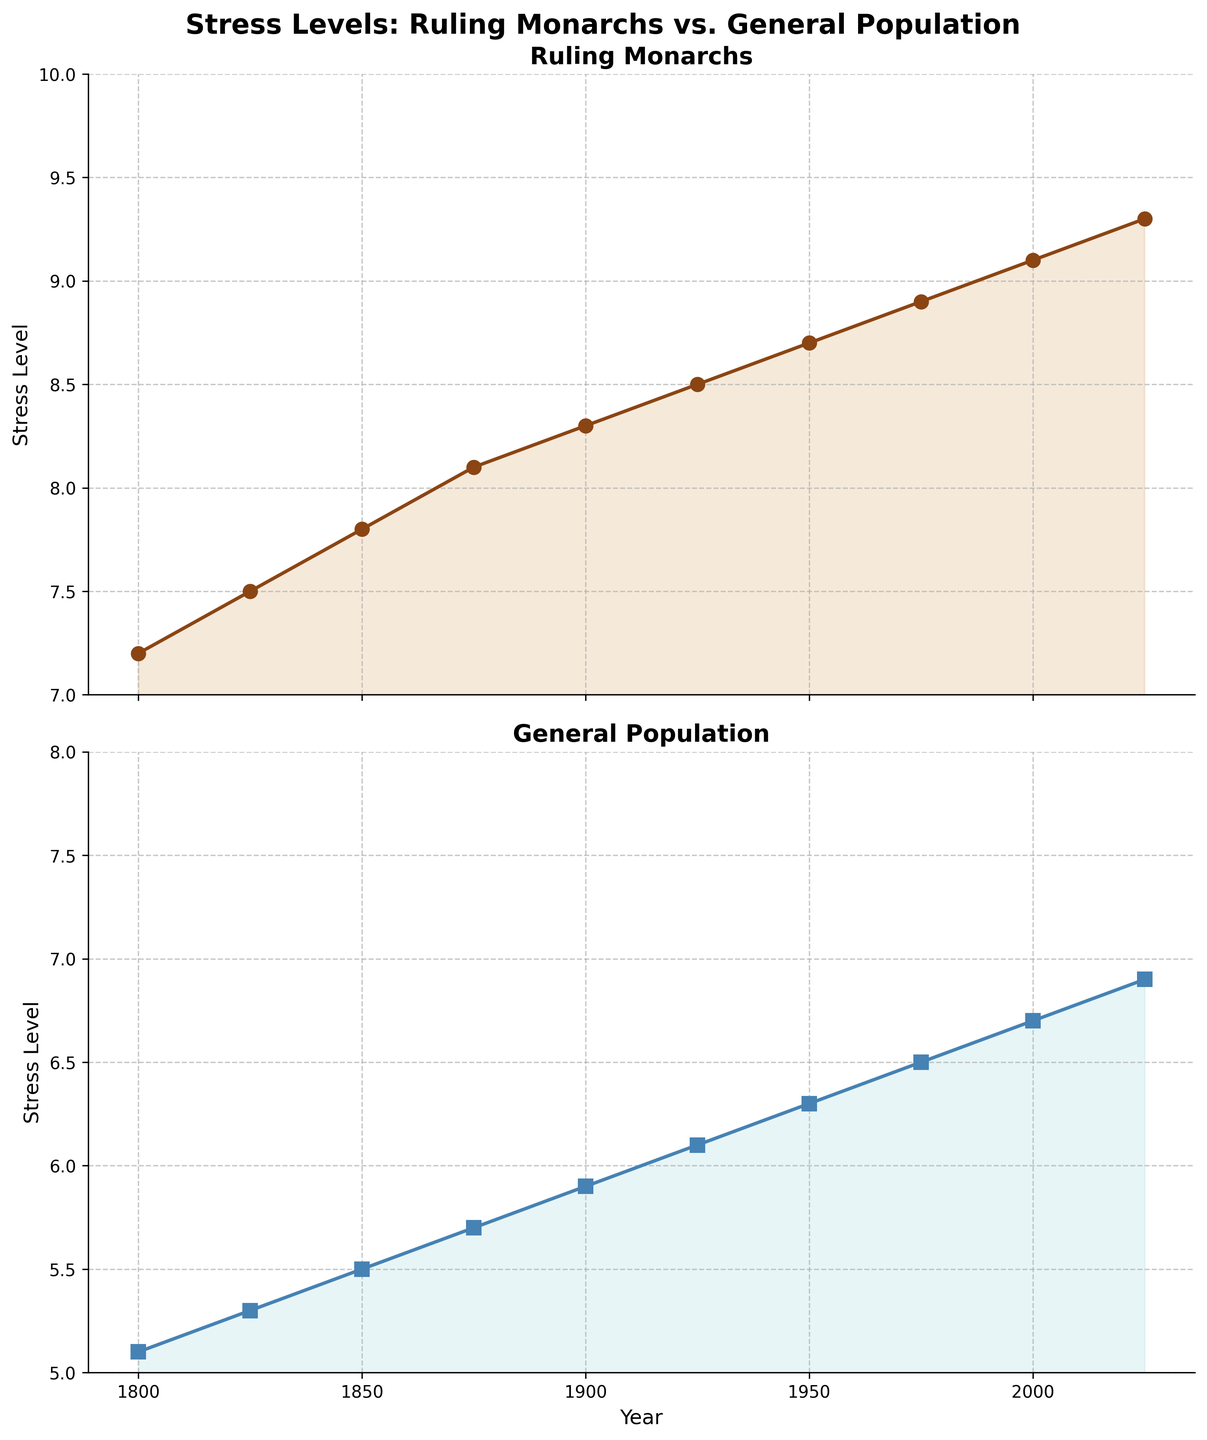What is the general trend of stress levels for ruling monarchs over time? The ruling monarchs' stress levels show a steady increase over time. From 1800 to 2025, the levels rise from 7.2 to 9.3.
Answer: An upward trend Compare the stress levels of ruling monarchs and the general population in the year 1900. Which is higher and by how much? In 1900, the stress level of ruling monarchs is 8.3, and for the general population, it is 5.9. The monarchs' stress levels are higher by 8.3 - 5.9 = 2.4.
Answer: Ruling monarchs, by 2.4 Between 1850 and 1900, which group shows a steeper increase in stress levels? For ruling monarchs, the increase is 8.3 - 7.8 = 0.5, and for the general population, it is 5.9 - 5.5 = 0.4. Monarchs have a steeper increase by 0.1.
Answer: Ruling monarchs Identify the time period (a span of 25 years) where the general population's stress level increased the most. Stress levels change: 1825-1800: 5.3-5.1=0.2, 1850-1825: 5.5-5.3=0.2, 1875-1850: 5.7-5.5=0.2, 1900-1875: 5.9-5.7=0.2, 1925-1900: 6.1-5.9=0.2, 1950-1925: 6.3-6.1=0.2, 1975-1950: 6.5-6.3=0.2, 2000-1975: 6.7-6.5=0.2, 2025-2000: 6.9-6.7=0.2. All increases are 0.2.
Answer: Any 25-year period between 1800 and 2025 